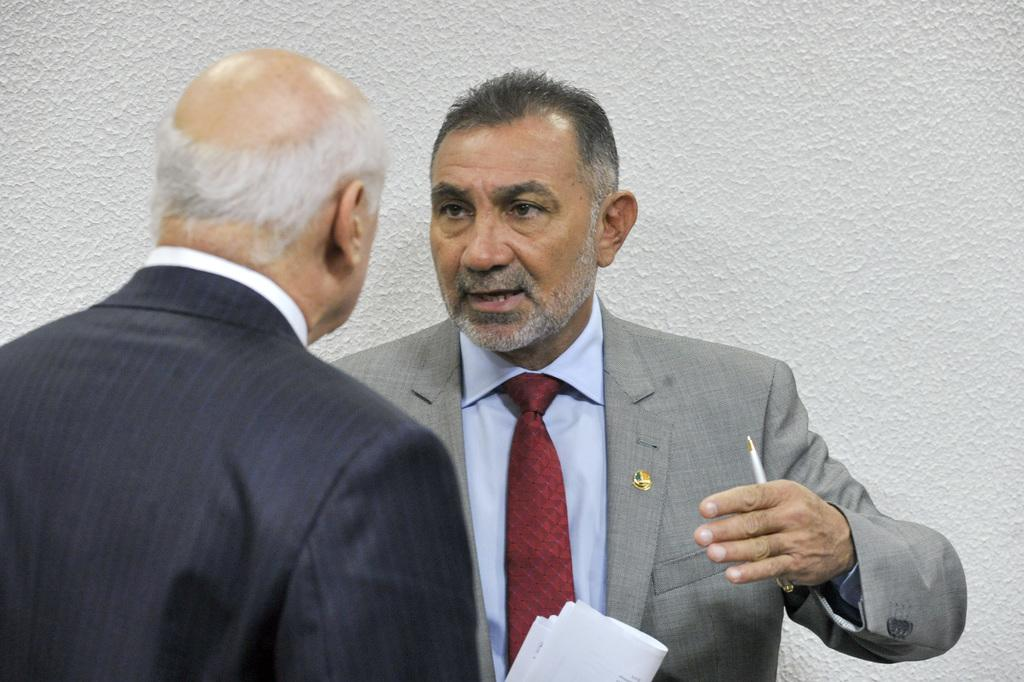How many people are in the image? There are two men in the image. What is one of the men holding? One of the men is holding a pen. What else can be seen in the image besides the men? There are papers visible in the image. What is visible in the background of the image? There is a wall in the background of the image. What type of honey is being collected by the donkey in the image? There is no donkey or honey present in the image. What type of stone is being used to write on the papers in the image? There is no stone visible in the image; only a pen is being used to write on the papers. 